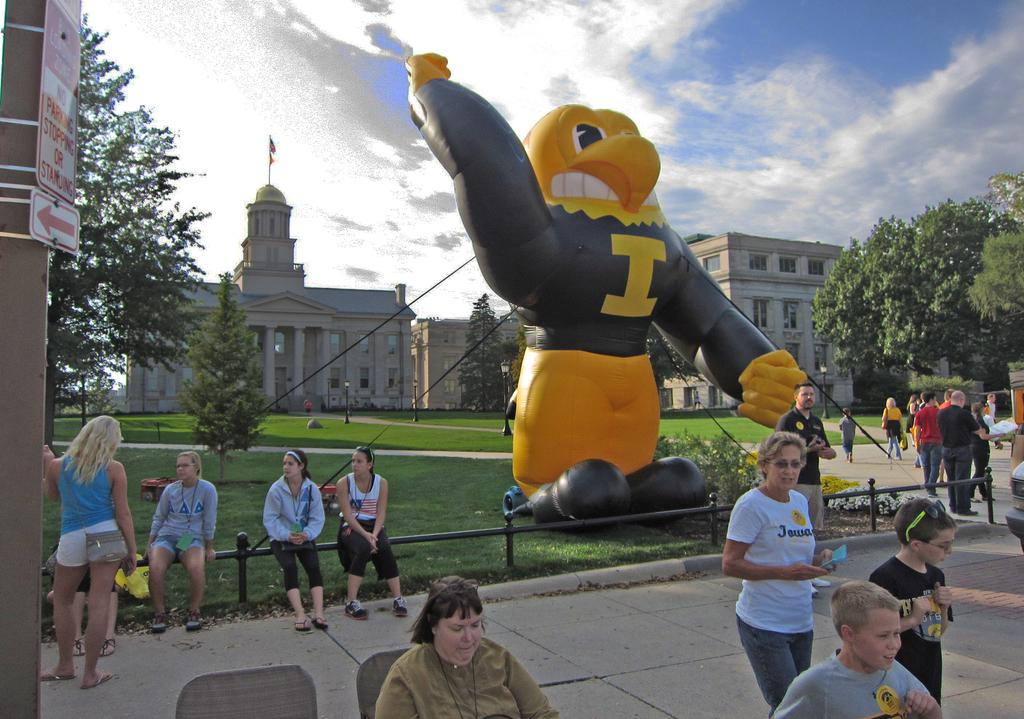<image>
Write a terse but informative summary of the picture. A giant bird mascot with the letter I on its shirt stands tall above the crowd 